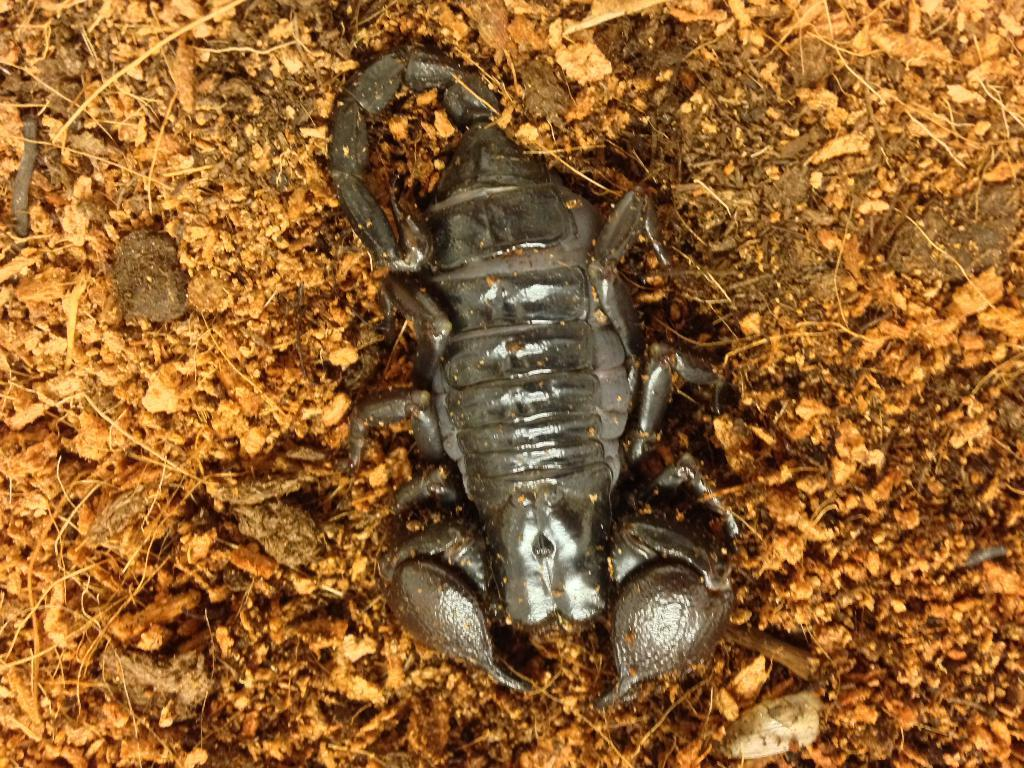What type of animal is in the image? There is a scorpion in the image. Where is the scorpion located? The scorpion is on the ground. How many chairs are visible in the image? There are no chairs present in the image; it features a scorpion on the ground. What type of material is the brick made of in the image? There is no brick present in the image. 